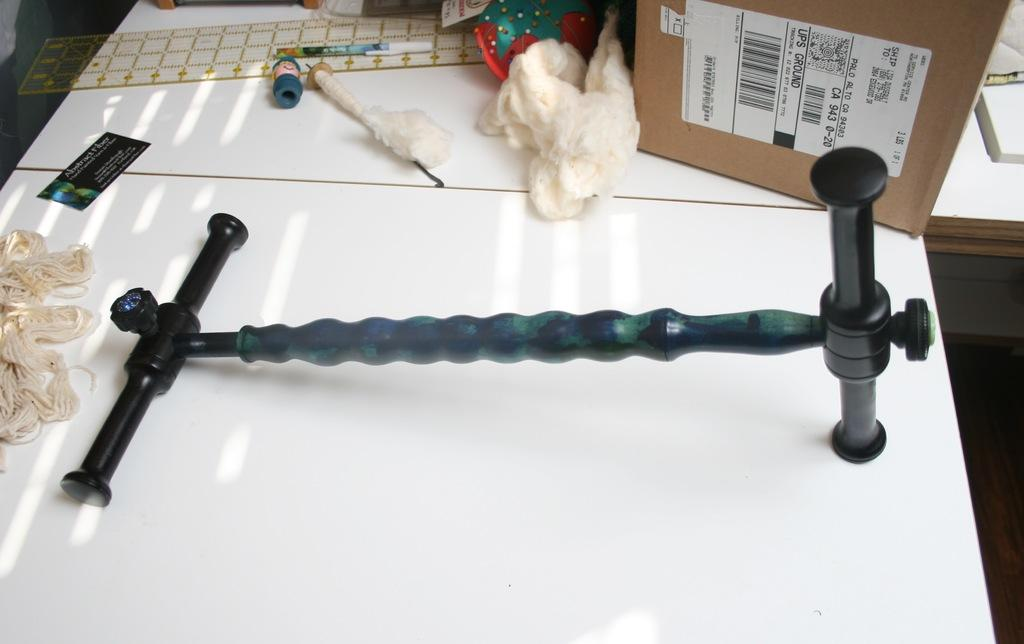What piece of furniture is present in the image? There is a table in the image. What is placed on top of the table? There is a cardboard box, a pan, and a card with text on the table. Can you describe the card with text? The card with text is a flat object with writing or symbols on it. What other unspecified objects can be seen on the table? There are other unspecified objects on the table, but their details are not mentioned in the facts. How does the soap on the table contribute to the flight of the potato? There is no soap or potato present in the image, so this question cannot be answered. 